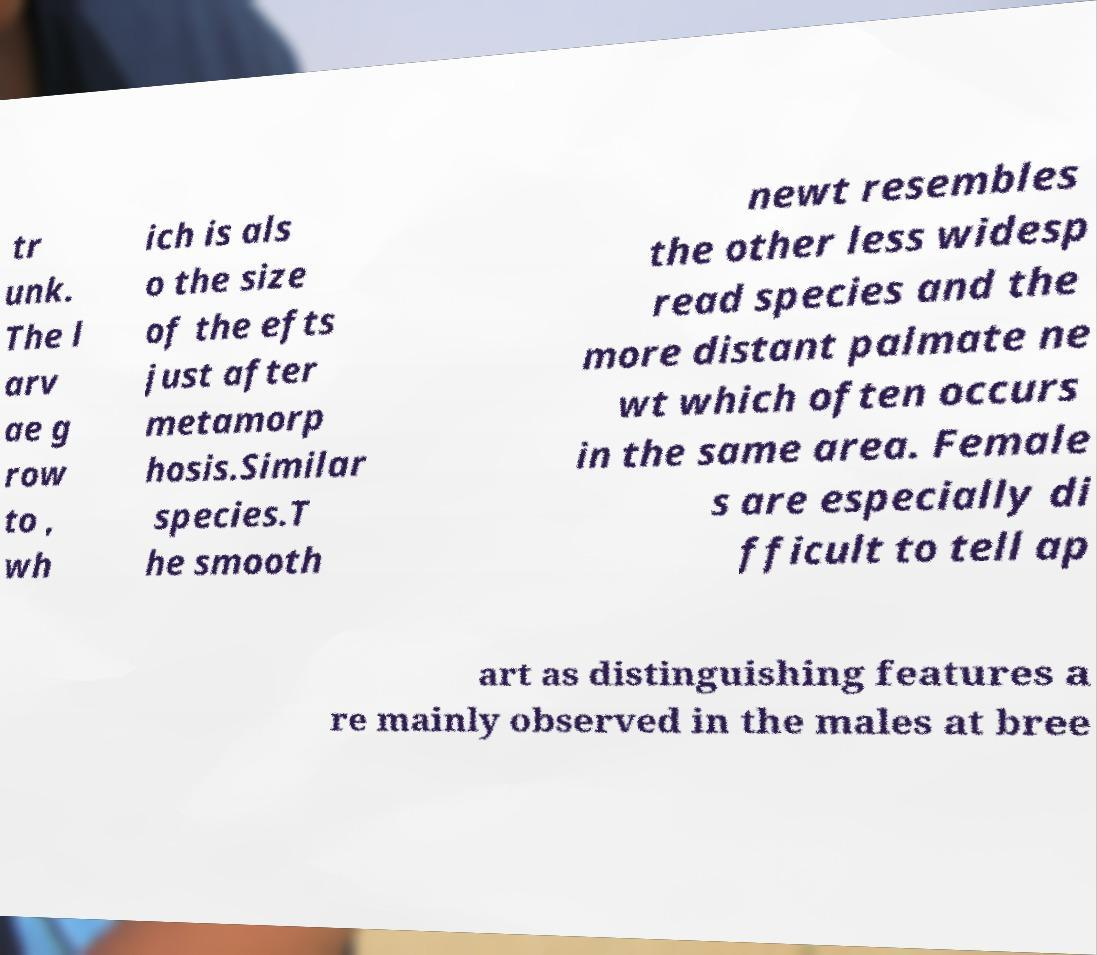There's text embedded in this image that I need extracted. Can you transcribe it verbatim? tr unk. The l arv ae g row to , wh ich is als o the size of the efts just after metamorp hosis.Similar species.T he smooth newt resembles the other less widesp read species and the more distant palmate ne wt which often occurs in the same area. Female s are especially di fficult to tell ap art as distinguishing features a re mainly observed in the males at bree 